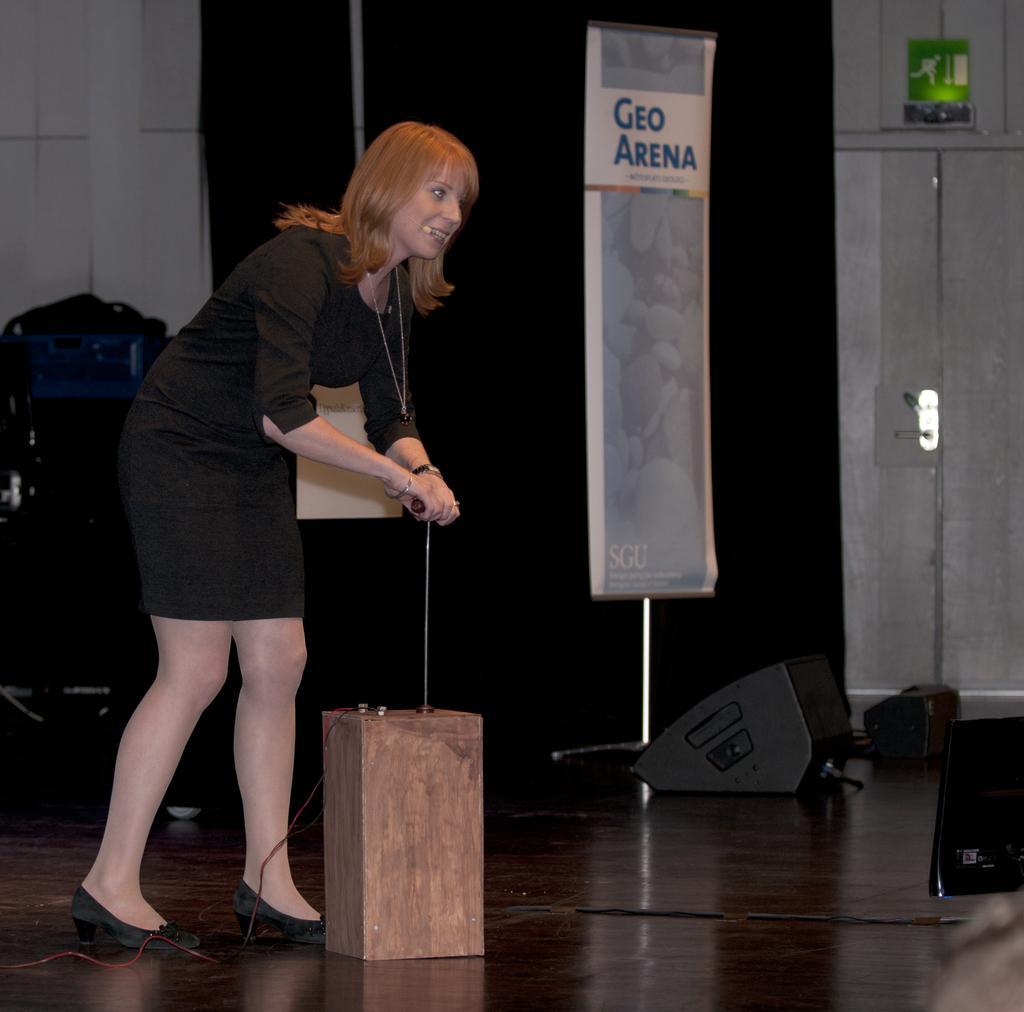Please provide a concise description of this image. In this image, we can see a woman is standing on the floor and holding an object. Here there is a box is connected with wires. Background we can see curtains, wall, door, sign board, banner, rod stand and few objects. 